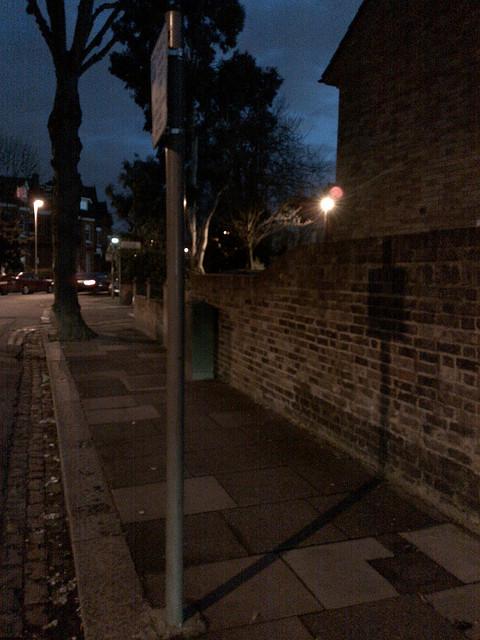Is there a sidewalk in the picture?
Keep it brief. Yes. Are there street lights on?
Be succinct. Yes. What is the wall for?
Give a very brief answer. Protection. Is there grass in the image?
Write a very short answer. No. What do you call this time of day?
Keep it brief. Night. 